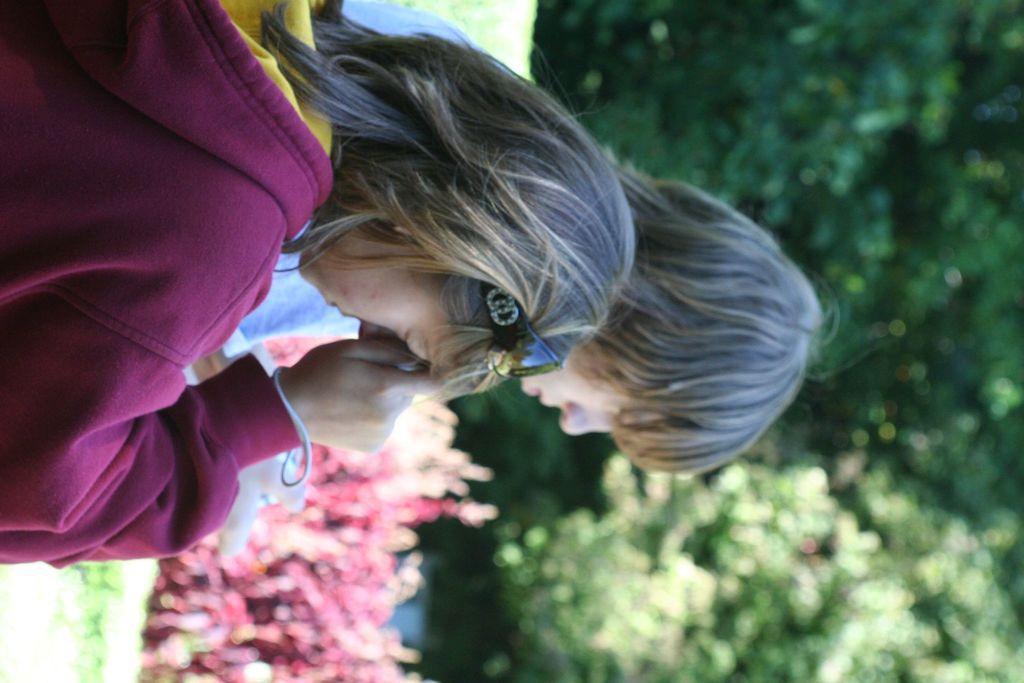In one or two sentences, can you explain what this image depicts? In this picture there are people in the image and there is greenery in the background area of the image, it seems to be there are red color plants in the image. 